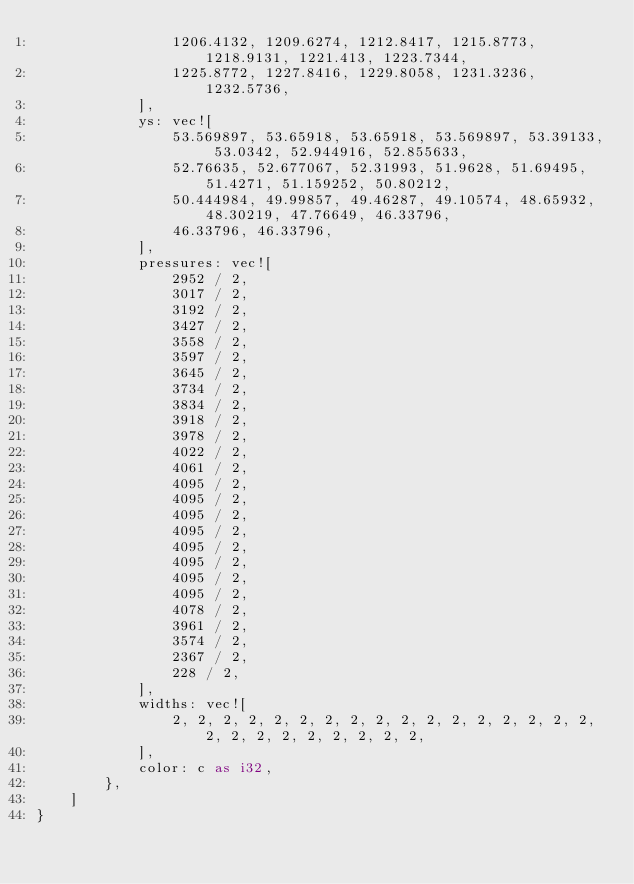Convert code to text. <code><loc_0><loc_0><loc_500><loc_500><_Rust_>                1206.4132, 1209.6274, 1212.8417, 1215.8773, 1218.9131, 1221.413, 1223.7344,
                1225.8772, 1227.8416, 1229.8058, 1231.3236, 1232.5736,
            ],
            ys: vec![
                53.569897, 53.65918, 53.65918, 53.569897, 53.39133, 53.0342, 52.944916, 52.855633,
                52.76635, 52.677067, 52.31993, 51.9628, 51.69495, 51.4271, 51.159252, 50.80212,
                50.444984, 49.99857, 49.46287, 49.10574, 48.65932, 48.30219, 47.76649, 46.33796,
                46.33796, 46.33796,
            ],
            pressures: vec![
                2952 / 2,
                3017 / 2,
                3192 / 2,
                3427 / 2,
                3558 / 2,
                3597 / 2,
                3645 / 2,
                3734 / 2,
                3834 / 2,
                3918 / 2,
                3978 / 2,
                4022 / 2,
                4061 / 2,
                4095 / 2,
                4095 / 2,
                4095 / 2,
                4095 / 2,
                4095 / 2,
                4095 / 2,
                4095 / 2,
                4095 / 2,
                4078 / 2,
                3961 / 2,
                3574 / 2,
                2367 / 2,
                228 / 2,
            ],
            widths: vec![
                2, 2, 2, 2, 2, 2, 2, 2, 2, 2, 2, 2, 2, 2, 2, 2, 2, 2, 2, 2, 2, 2, 2, 2, 2, 2,
            ],
            color: c as i32,
        },
    ]
}
</code> 